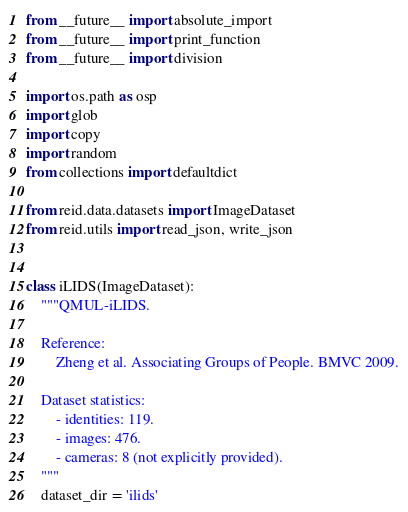Convert code to text. <code><loc_0><loc_0><loc_500><loc_500><_Python_>from __future__ import absolute_import
from __future__ import print_function
from __future__ import division

import os.path as osp
import glob
import copy
import random
from collections import defaultdict

from reid.data.datasets import ImageDataset
from reid.utils import read_json, write_json


class iLIDS(ImageDataset):
    """QMUL-iLIDS.

    Reference:
        Zheng et al. Associating Groups of People. BMVC 2009.
    
    Dataset statistics:
        - identities: 119.
        - images: 476. 
        - cameras: 8 (not explicitly provided).
    """
    dataset_dir = 'ilids'</code> 